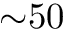Convert formula to latex. <formula><loc_0><loc_0><loc_500><loc_500>{ \sim } 5 0</formula> 